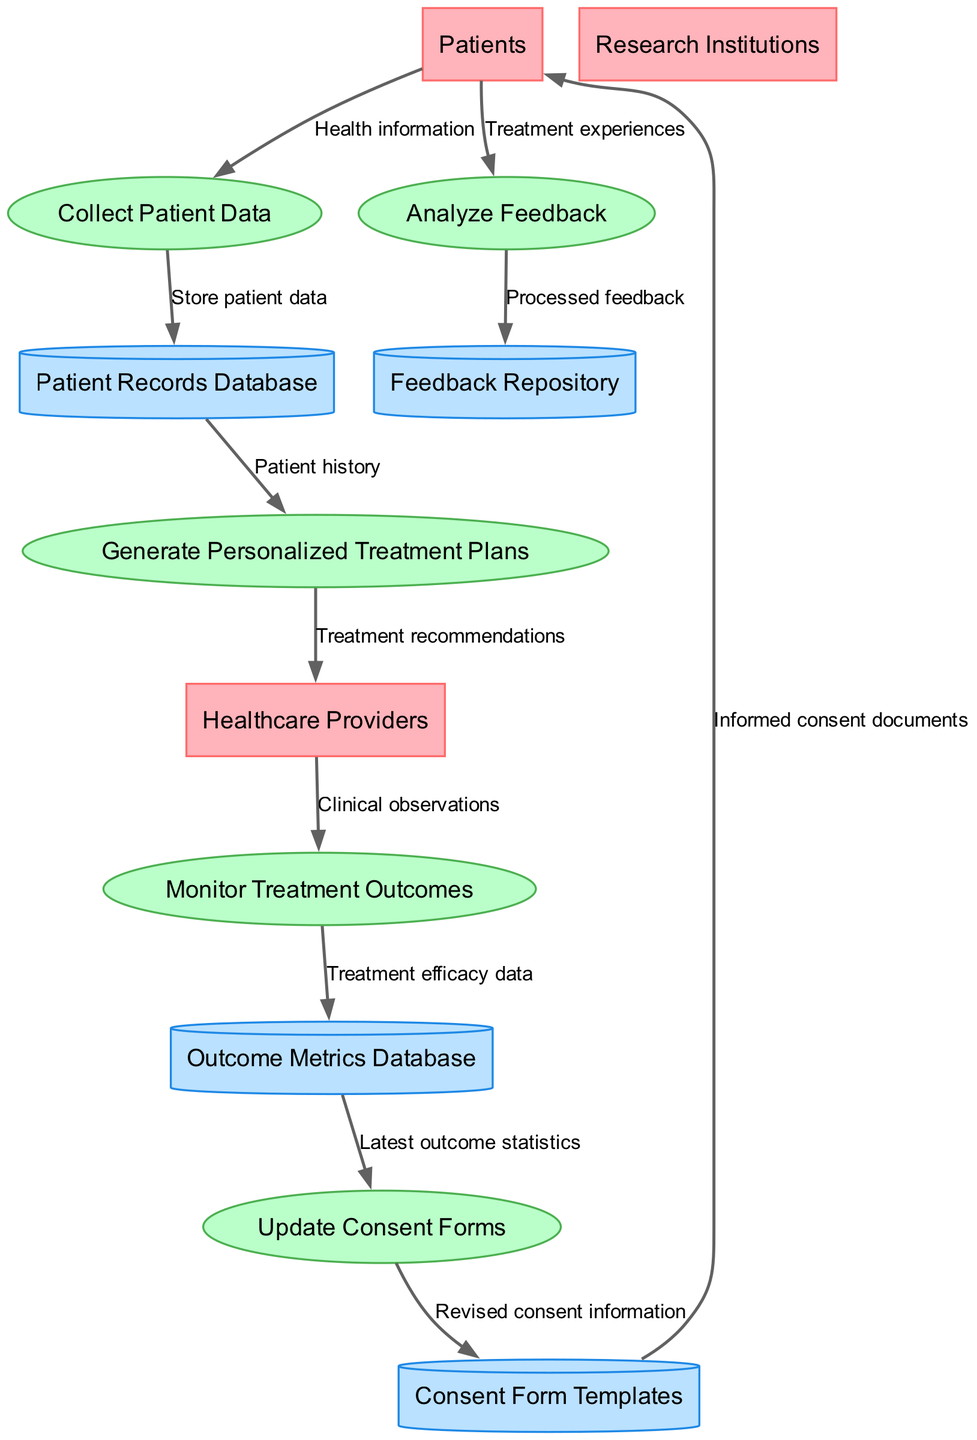What is the first process in the diagram? The diagram shows the process flow starting with "Collect Patient Data" as the first process indicated in the sequential order of operations.
Answer: Collect Patient Data How many external entities are present? There are three external entities listed in the diagram: Patients, Healthcare Providers, and Research Institutions. Counting them gives the number three.
Answer: 3 Which data store receives processed feedback? The "Feedback Repository" is the data store that receives processed feedback output from the process "Analyze Feedback." This relationship is explicitly stated in the diagram's data flow.
Answer: Feedback Repository What is the last process shown in the diagram? The last process in the diagram is "Update Consent Forms," which is the final element in the flow of processes depicted, indicating it follows after treatment outcome metrics are utilized.
Answer: Update Consent Forms What data flows from the Patient Records Database? From the "Patient Records Database," the data flow leads to "Generate Personalized Treatment Plans," which indicates the use of patient history for creating treatment recommendations.
Answer: Patient history How does feedback from patients contribute to the healthcare provider's actions? Patient feedback is initially collected and analyzed, which subsequently informs the process of generating personalized treatment plans. These treatment recommendations are then sent to Healthcare Providers, indicating a direct influence of patient feedback on provider actions.
Answer: Treatment recommendations Which data store holds treatment efficacy data? The data store that holds treatment efficacy data is the "Outcome Metrics Database," which is specifically mentioned as receiving data from the process "Monitor Treatment Outcomes."
Answer: Outcome Metrics Database What type of information is stored in Consent Form Templates? The "Consent Form Templates" store "Revised consent information," which is generated from the process "Update Consent Forms." This shows how consent design elements are systematically updated.
Answer: Revised consent information 